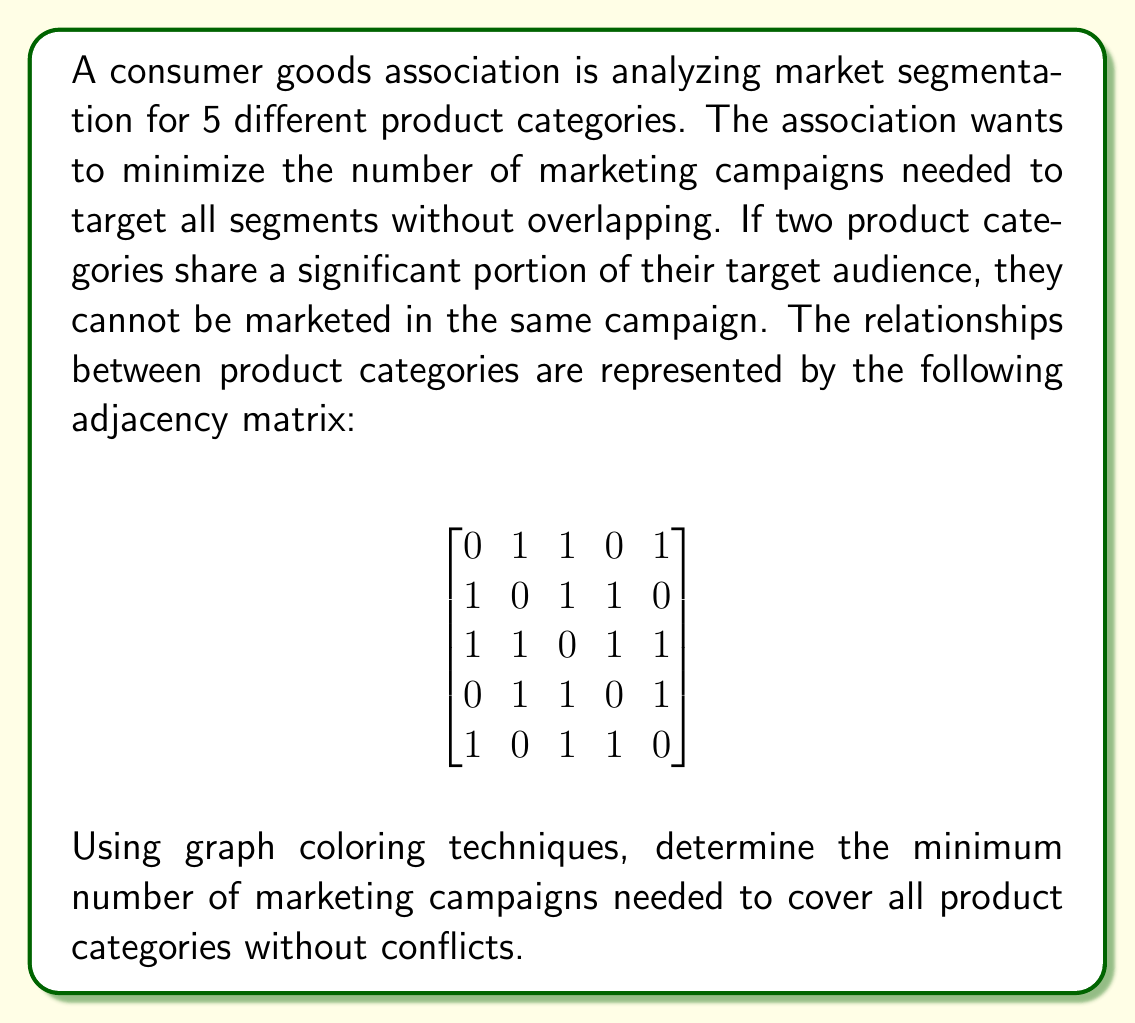Show me your answer to this math problem. To solve this problem, we'll use graph coloring techniques:

1) First, we interpret the adjacency matrix as a graph where:
   - Each product category is a vertex
   - An edge exists between two vertices if they share a significant audience (represented by 1 in the matrix)

2) In graph coloring, each color represents a marketing campaign. Adjacent vertices (conflicting categories) must have different colors.

3) We'll use a greedy coloring algorithm:
   - Start with the first vertex and assign it color 1
   - For each subsequent vertex, assign the lowest-numbered color that hasn't been used on any adjacent vertices

4) Let's color the graph:
   - Vertex 1: Color 1
   - Vertex 2: Adjacent to 1, so Color 2
   - Vertex 3: Adjacent to 1 and 2, so Color 3
   - Vertex 4: Adjacent to 2 and 3, but not 1, so Color 1
   - Vertex 5: Adjacent to 1 and 3, but not 2, so Color 2

5) The number of distinct colors used is the chromatic number of the graph, which represents the minimum number of marketing campaigns needed.

[asy]
unitsize(30);
pair[] v = {(0,0), (2,0), (1,1.732), (-1,1.732), (-2,0)};
for(int i = 0; i < 5; ++i)
  draw(circle(v[i], 0.3), fill(i == 0 || i == 3 ? red : i == 1 || i == 4 ? blue : green));
draw(v[0]--v[1]--v[2]--v[3]--v[4]--v[0]);
draw(v[0]--v[2]--v[4]);
draw(v[1]--v[3]);
label("1", v[0]);
label("2", v[1]);
label("3", v[2]);
label("4", v[3]);
label("5", v[4]);
[/asy]

In this colored graph, we can see that 3 colors are used, representing 3 distinct marketing campaigns.
Answer: The minimum number of marketing campaigns needed is 3. 